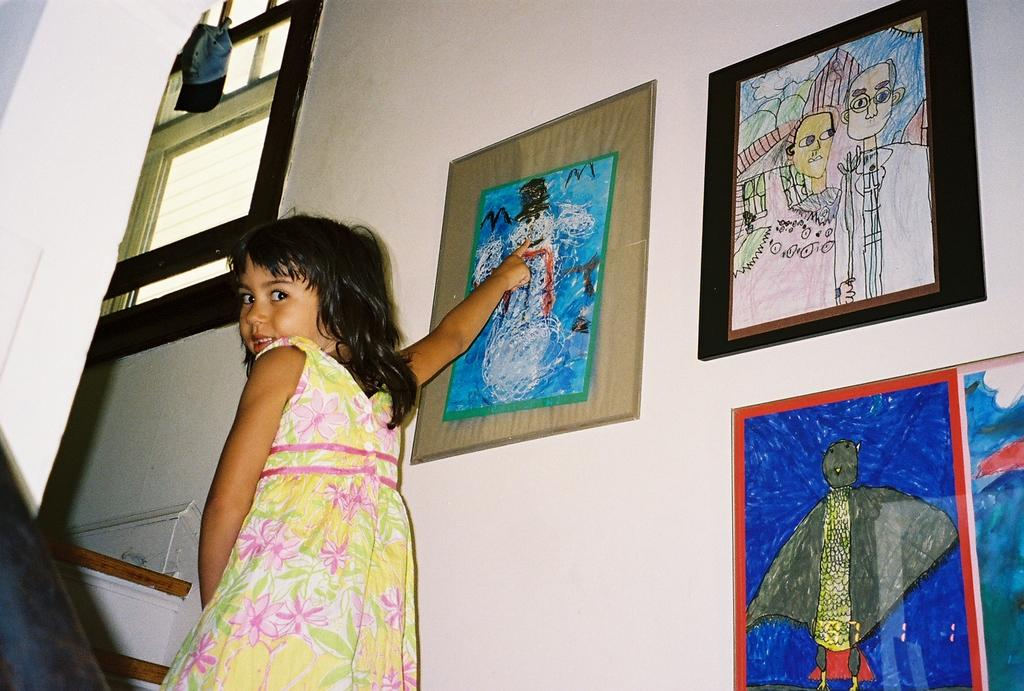Who is in the image? There is a girl in the image. What is the girl doing in the image? The girl is standing and smiling. What can be seen behind the girl? There is a wall behind the girl. What is on the wall? There are drawings on the wall and a window. What is on the window? There is a cap on the window. What type of muscle can be seen flexing in the image? There is no muscle visible in the image; it features a girl standing and smiling. How does the sleet affect the drawings on the wall in the image? There is no sleet present in the image, so it cannot affect the drawings on the wall. 